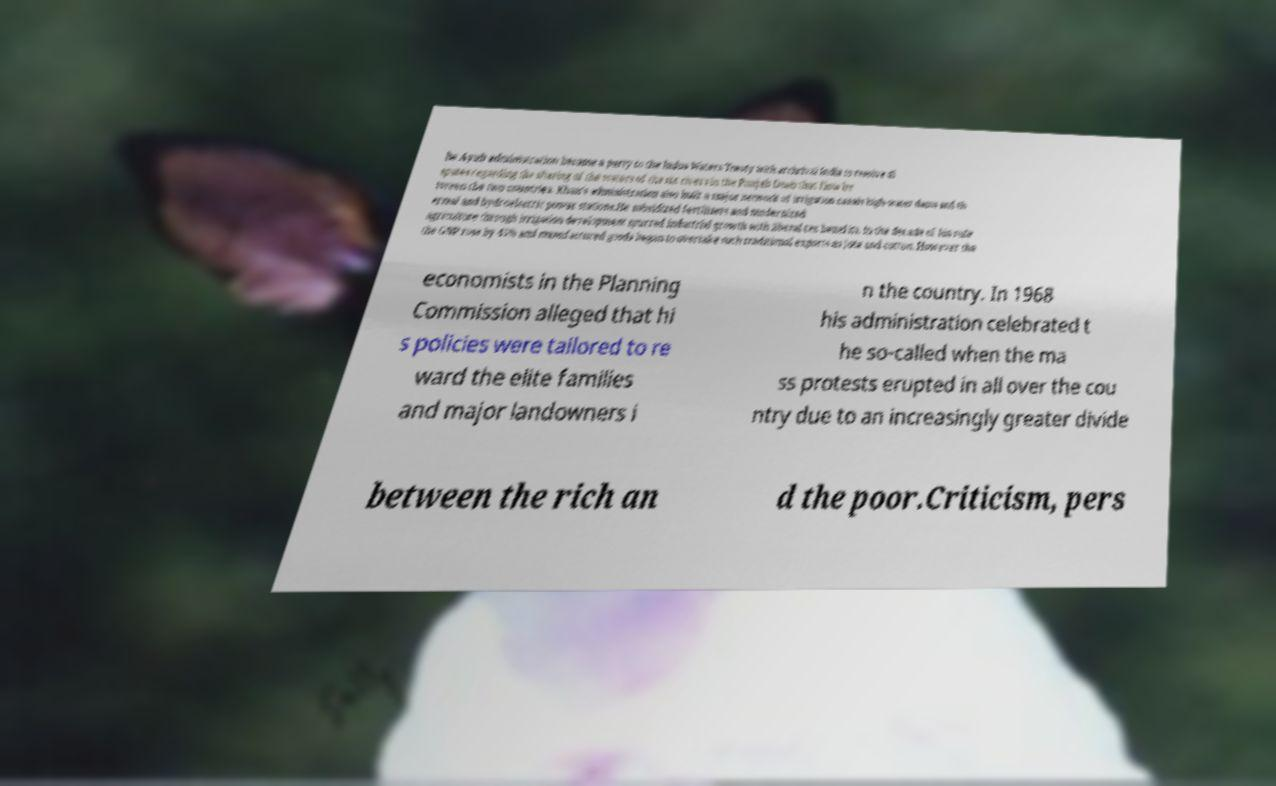For documentation purposes, I need the text within this image transcribed. Could you provide that? he Ayub administration became a party to the Indus Waters Treaty with archrival India to resolve di sputes regarding the sharing of the waters of the six rivers in the Punjab Doab that flow be tween the two countries. Khan's administration also built a major network of irrigation canals high-water dams and th ermal and hydroelectric power stations.He subsidized fertilizers and modernized agriculture through irrigation development spurred industrial growth with liberal tax benefits. In the decade of his rule the GNP rose by 45% and manufactured goods began to overtake such traditional exports as jute and cotton. However the economists in the Planning Commission alleged that hi s policies were tailored to re ward the elite families and major landowners i n the country. In 1968 his administration celebrated t he so-called when the ma ss protests erupted in all over the cou ntry due to an increasingly greater divide between the rich an d the poor.Criticism, pers 